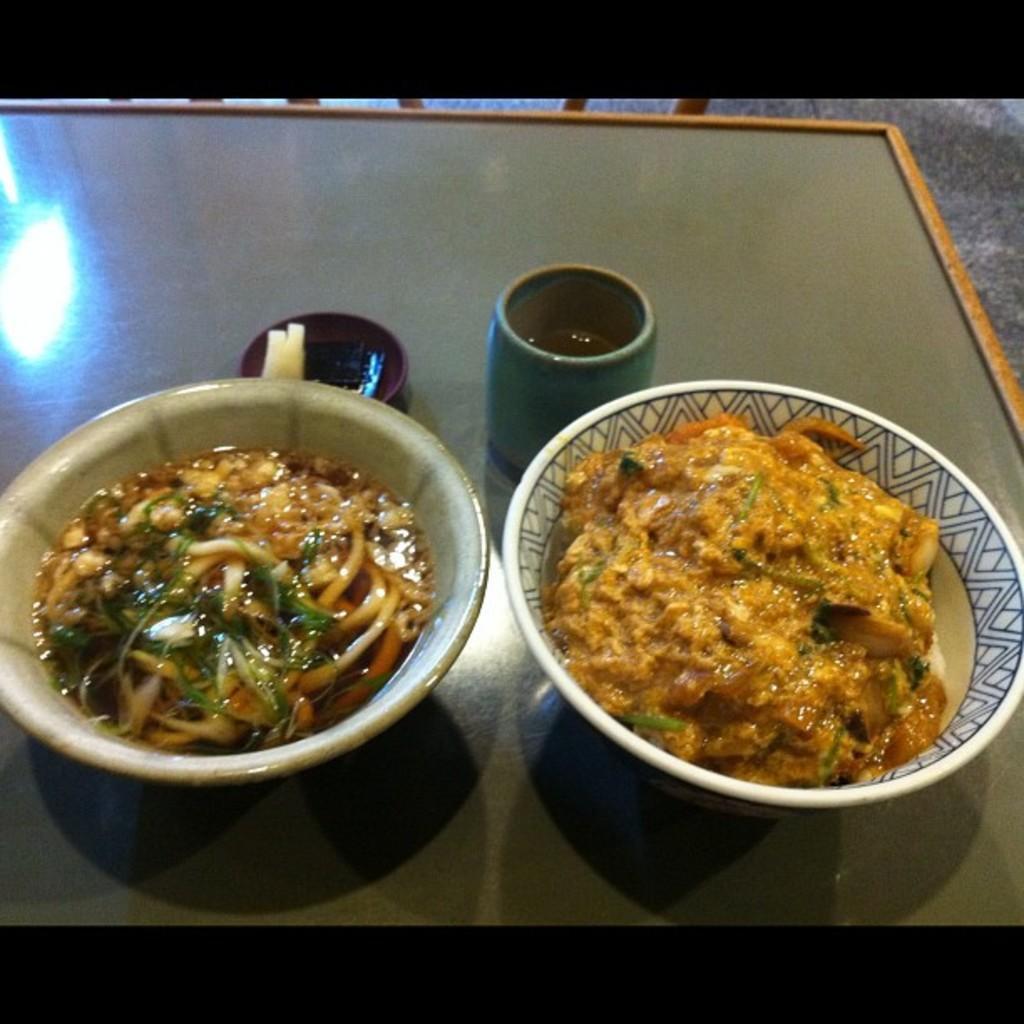In one or two sentences, can you explain what this image depicts? On a table there are 2 bowls of food items. There is a glass of drink. 